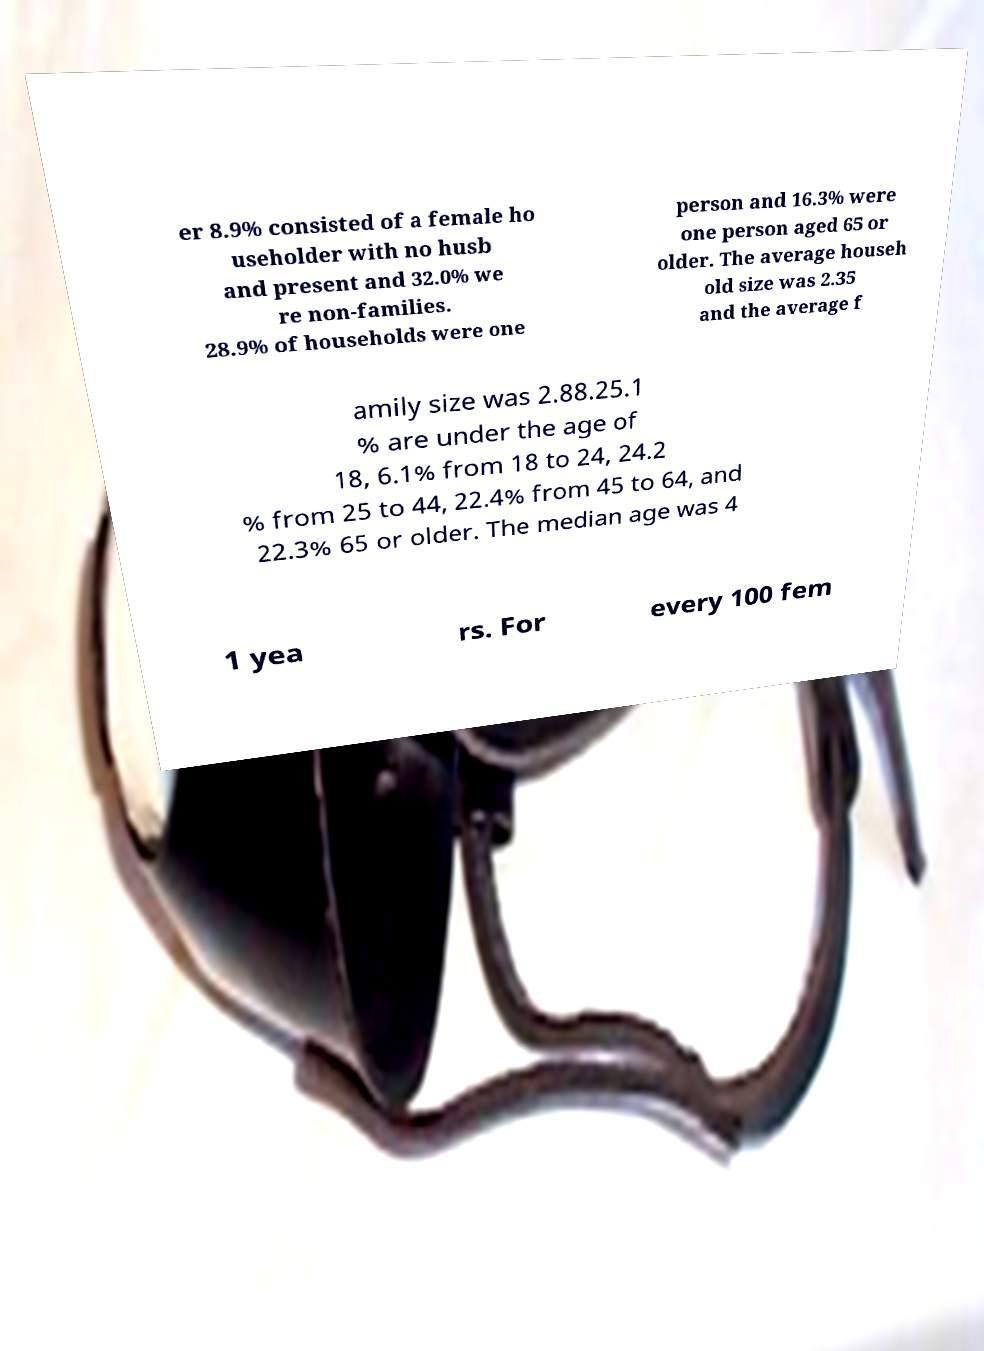What messages or text are displayed in this image? I need them in a readable, typed format. er 8.9% consisted of a female ho useholder with no husb and present and 32.0% we re non-families. 28.9% of households were one person and 16.3% were one person aged 65 or older. The average househ old size was 2.35 and the average f amily size was 2.88.25.1 % are under the age of 18, 6.1% from 18 to 24, 24.2 % from 25 to 44, 22.4% from 45 to 64, and 22.3% 65 or older. The median age was 4 1 yea rs. For every 100 fem 